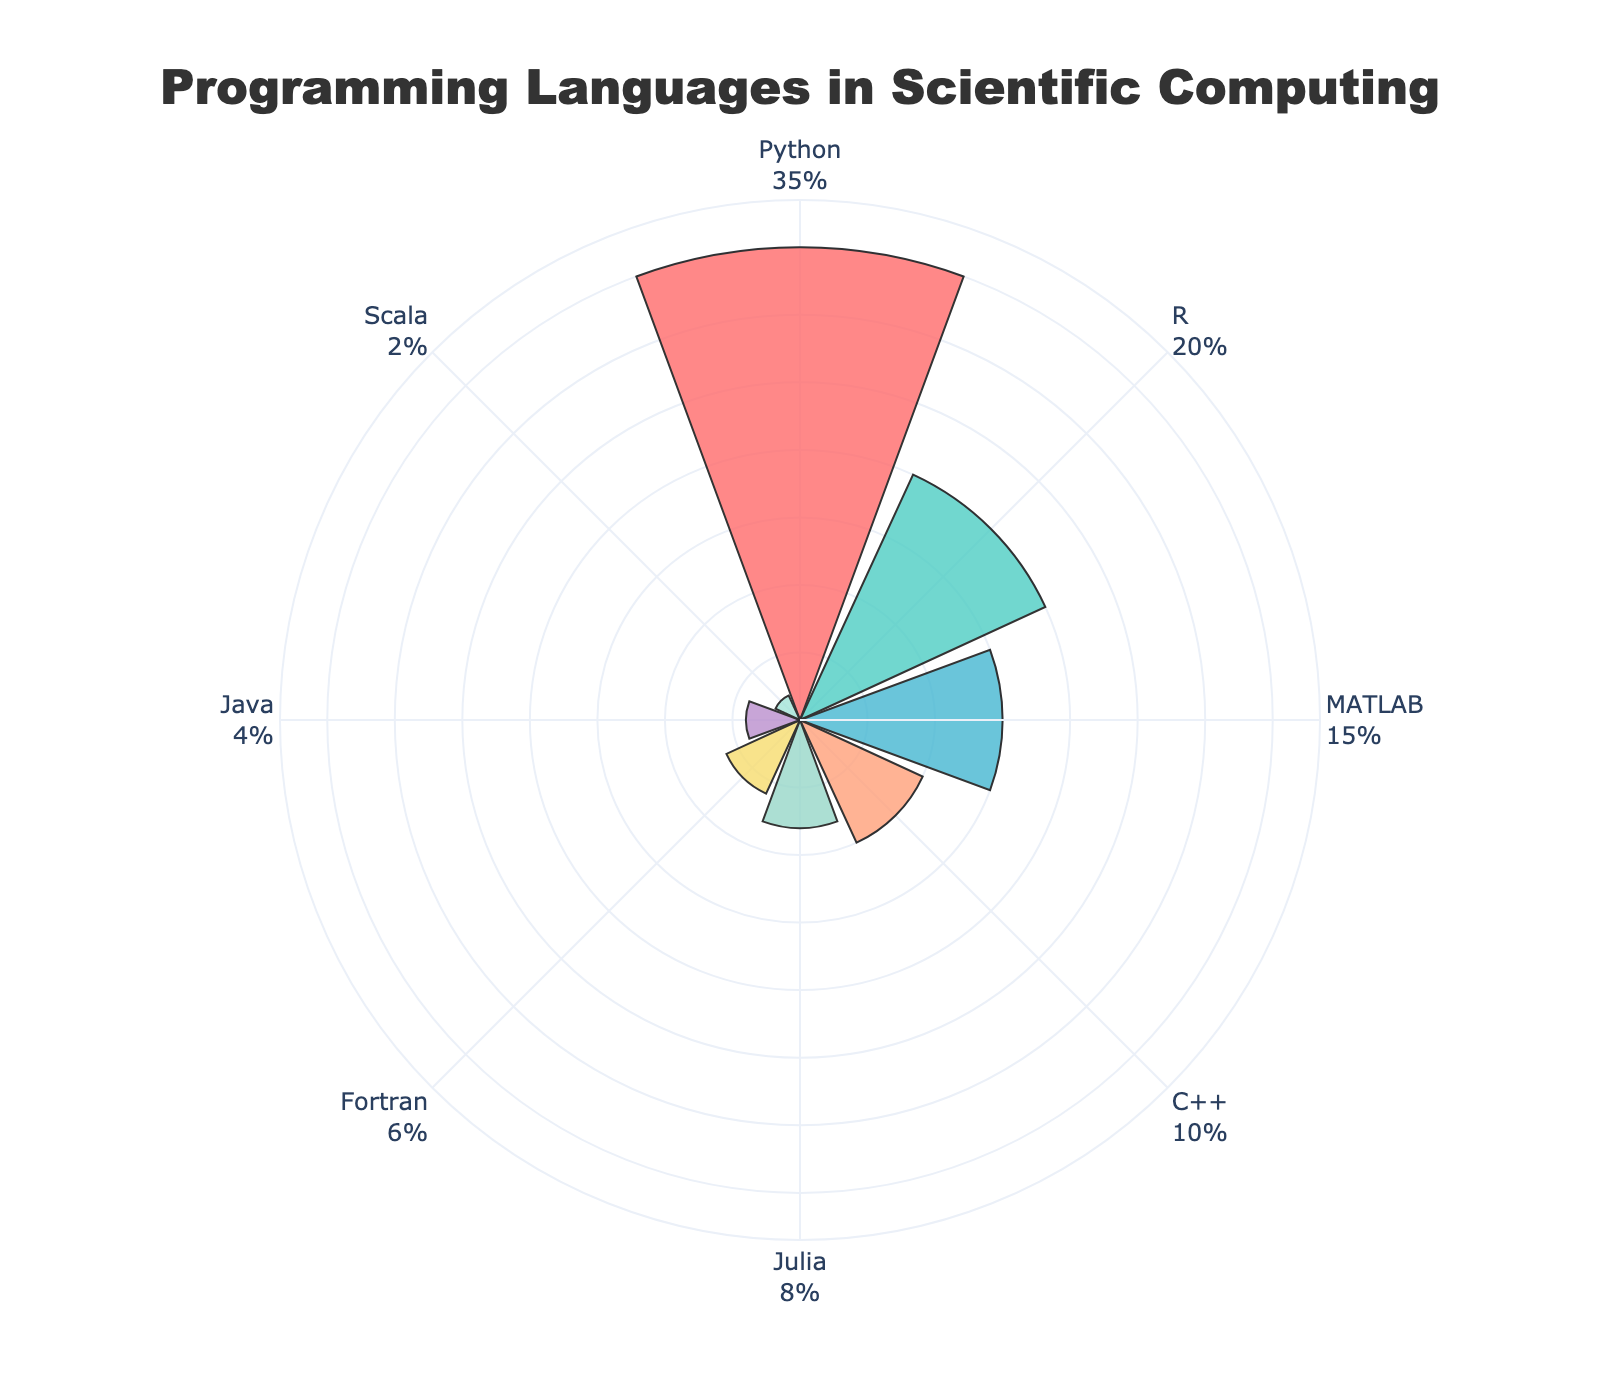What's the title of the figure? The title is usually positioned at the top of the figure and is commonly used to provide an overview or summary of what the chart represents. Here, the title is centered and mentions "Programming Languages in Scientific Computing."
Answer: Programming Languages in Scientific Computing Which programming language has the highest frequency? To find the programming language with the highest frequency, look for the largest segment or the one with the highest radial value on the figure. The chart will show Python with the largest bar, indicating its highest frequency.
Answer: Python What is the total frequency of languages used in the chart? Sum the frequency values of all programming languages listed in the chart: 35 (Python) + 20 (R) + 15 (MATLAB) + 10 (C++) + 8 (Julia) + 6 (Fortran) + 4 (Java) + 2 (Scala). This gives a total frequency.
Answer: 100 How many programming languages are represented in the chart? Count the number of distinct segments or entries in the chart, where each entry corresponds to a specific programming language. The rose chart has 8 segments.
Answer: 8 What is the frequency difference between Python and MATLAB? Subtract the frequency of MATLAB (15) from the frequency of Python (35). The result gives the difference in frequency between the two programming languages.
Answer: 20 Which language has a frequency closer to Julia, Fortran, or Java? Look at the frequencies of Julia, Fortran, and Java and compare them to Julia's frequency (8%). Fortran has a frequency of 6%, which is closer to 8% than Java's 4%.
Answer: Fortran What are the colors used in the chart to represent different languages? Identify the different colors used in the chart by examining the segments, ensuring not to use technical color terms. You will see colors like red, green, blue, orange, yellow, violet, light green, and light blue.
Answer: Red, Green, Blue, Orange, Yellow, Violet, Light Green, Light Blue Which language is represented by the smallest segment on the chart? Look for the segment with the smallest radial value. The smallest segment corresponds to Scala, which has the lowest frequency.
Answer: Scala What's the combined frequency of R, MATLAB, and C++? Add the frequencies of R (20), MATLAB (15), and C++ (10). The combined frequency is the sum of these values.
Answer: 45 Which language has a lower frequency than Java but higher than Scala? Compare the frequency values of Java (4%) and Scala (2%). Find the language that falls in between these values. Fortran has a frequency of 6%, fitting the criteria.
Answer: Fortran 